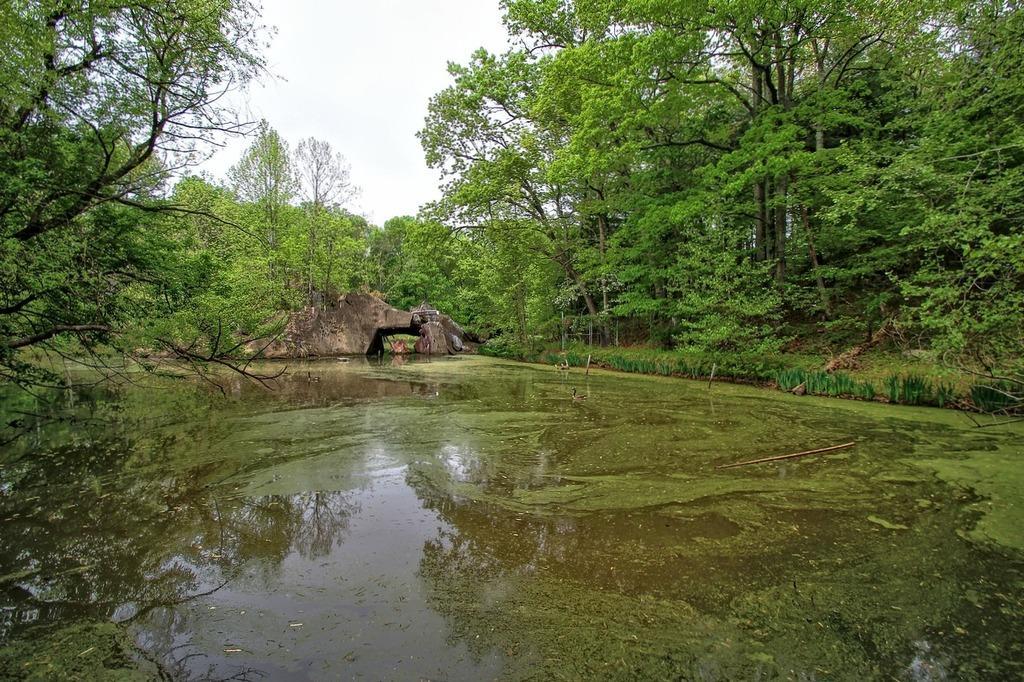Describe this image in one or two sentences. In the picture we can see the water, stones, trees on either side of the image and the sky in the background. 